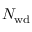<formula> <loc_0><loc_0><loc_500><loc_500>N _ { w d }</formula> 